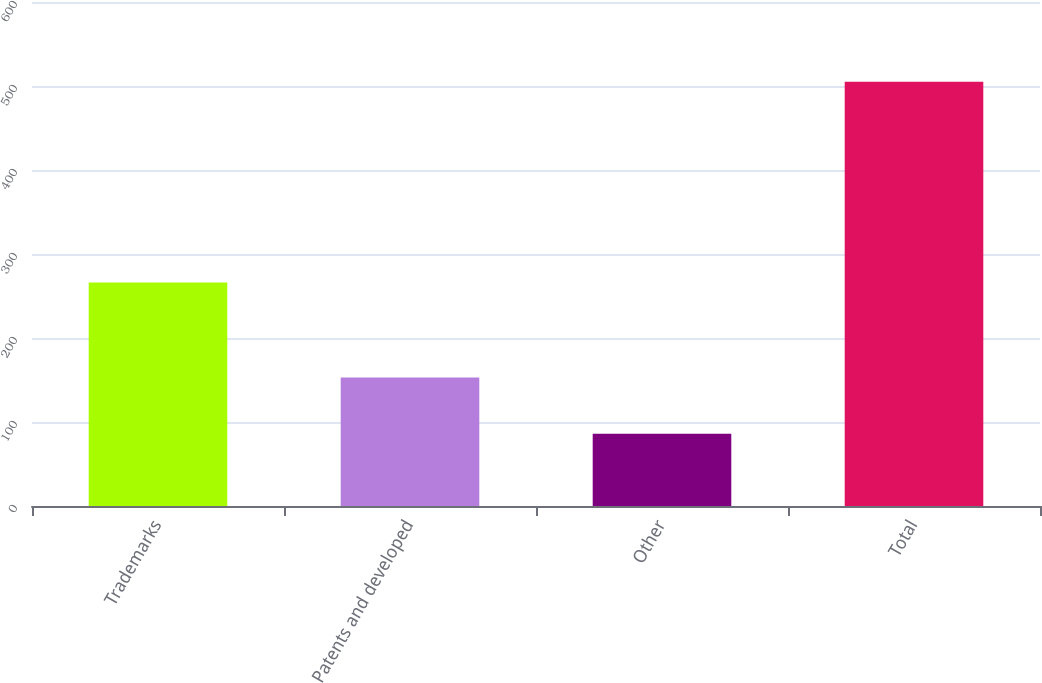Convert chart. <chart><loc_0><loc_0><loc_500><loc_500><bar_chart><fcel>Trademarks<fcel>Patents and developed<fcel>Other<fcel>Total<nl><fcel>266<fcel>153<fcel>86<fcel>505<nl></chart> 